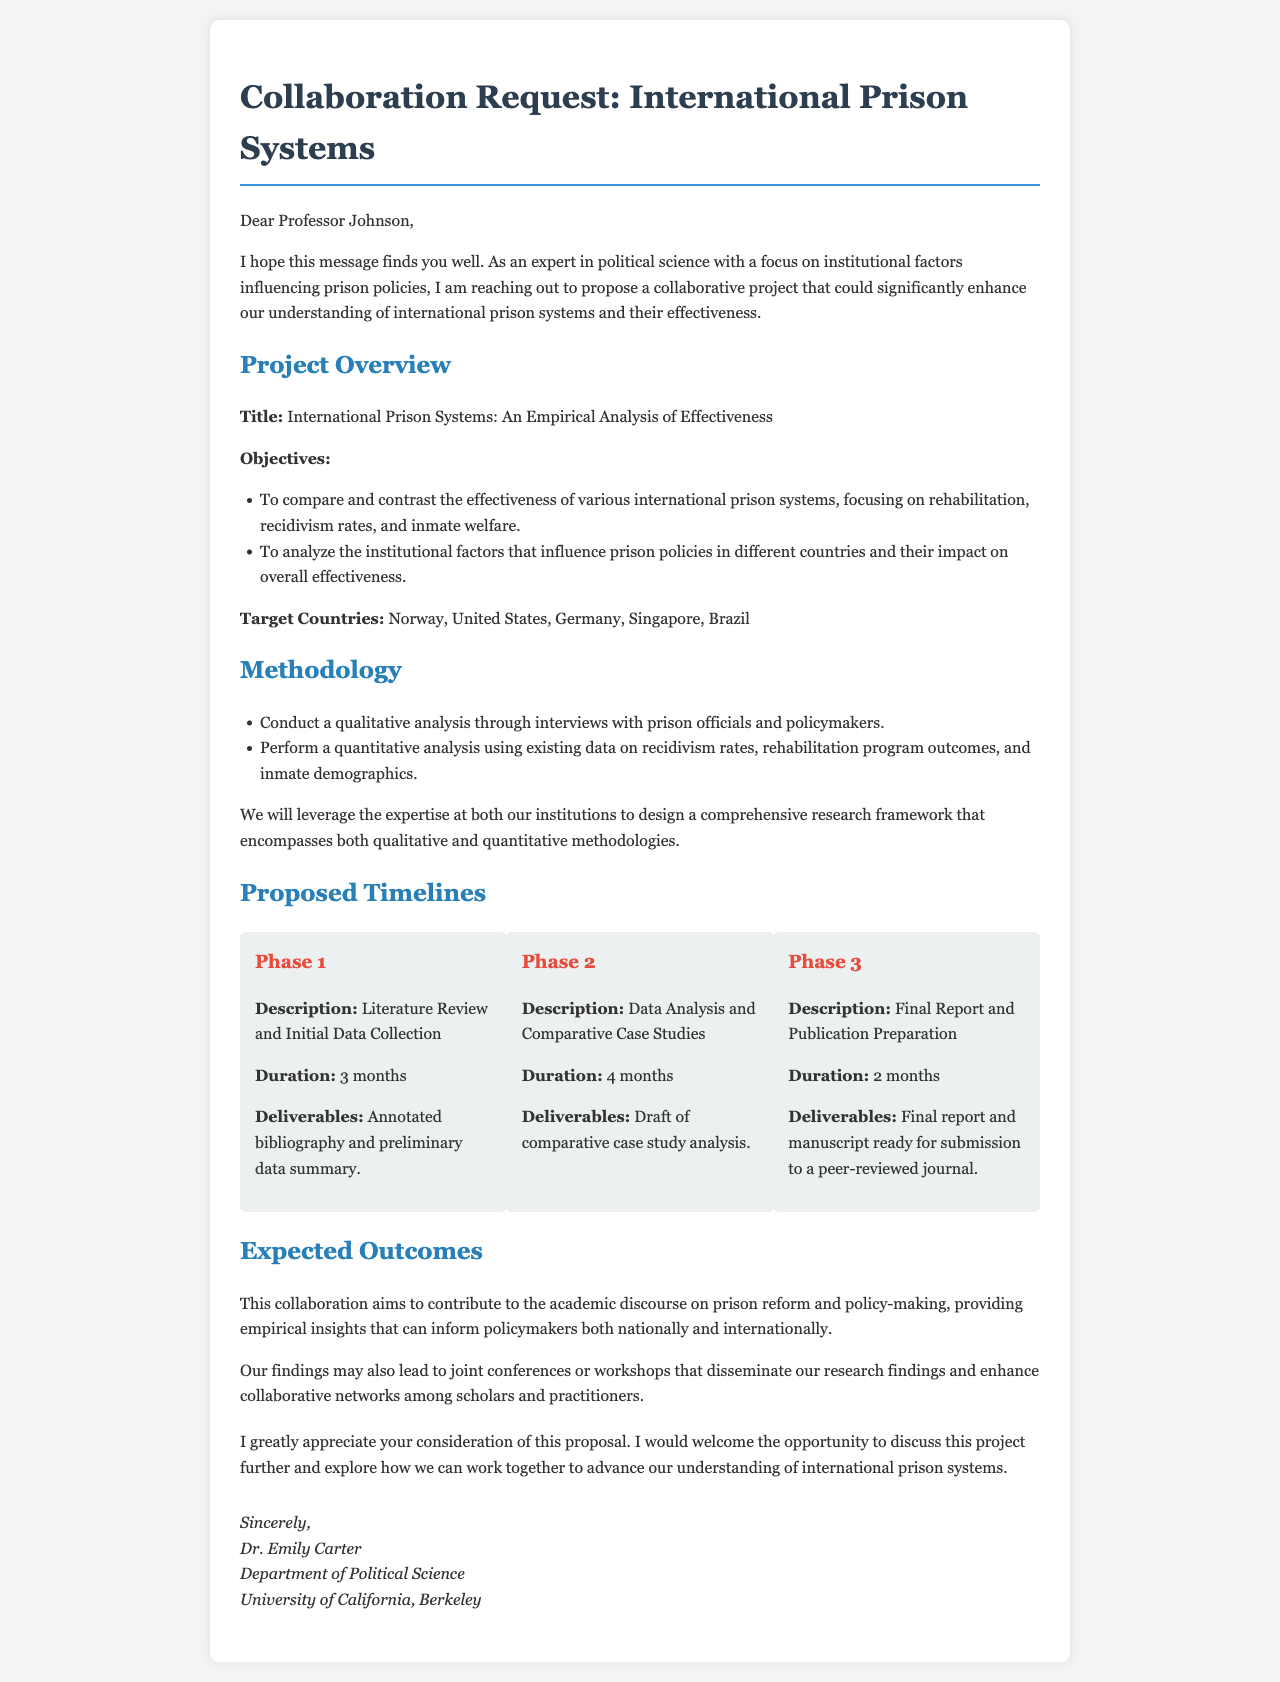What is the title of the proposed project? The title of the proposed project is stated clearly in the document as "International Prison Systems: An Empirical Analysis of Effectiveness."
Answer: International Prison Systems: An Empirical Analysis of Effectiveness Who is proposing the collaboration? The document mentions "Dr. Emily Carter" as the sender of the proposal, who is proposing the collaboration.
Answer: Dr. Emily Carter How many target countries are mentioned? The document lists a total of five target countries for the project.
Answer: Five What is the duration of Phase 1? The document specifies that Phase 1, which covers the literature review and initial data collection, will last for 3 months.
Answer: 3 months What are the expected outcomes of the collaboration? The document states that the expected outcomes include contributing to the academic discourse on prison reform and policy-making.
Answer: Contribute to the academic discourse on prison reform and policy-making What methodology will be used for the project? The document outlines that both qualitative and quantitative analyses will be conducted as part of the methodology for the project.
Answer: Qualitative and quantitative analyses What is the final deliverable of Phase 3? According to the document, the final deliverable for Phase 3 is the final report and manuscript ready for submission to a peer-reviewed journal.
Answer: Final report and manuscript ready for submission to a peer-reviewed journal What type of document is this? This document is a letter requesting collaboration on a research project.
Answer: Letter 